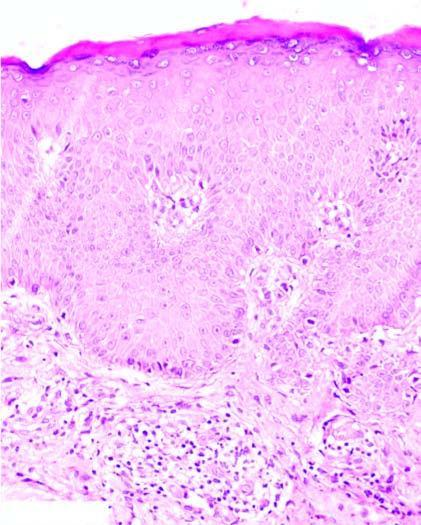what does the dermis show?
Answer the question using a single word or phrase. Mild perivascular chronic inflammatory cell infiltrate 